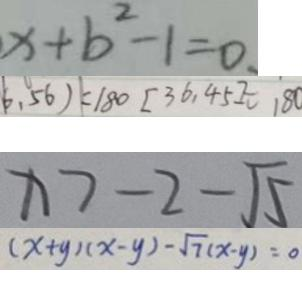Convert formula to latex. <formula><loc_0><loc_0><loc_500><loc_500>x + b ^ { 2 } - 1 = 0 . 
 6 , 5 6 ) = 1 8 0 [ 3 6 , 4 5 ] = 1 8 0 
 x > - 2 - \sqrt { 5 } 
 ( x + y ) ( x - y ) - \sqrt { 7 } ( x - y ) = 0</formula> 